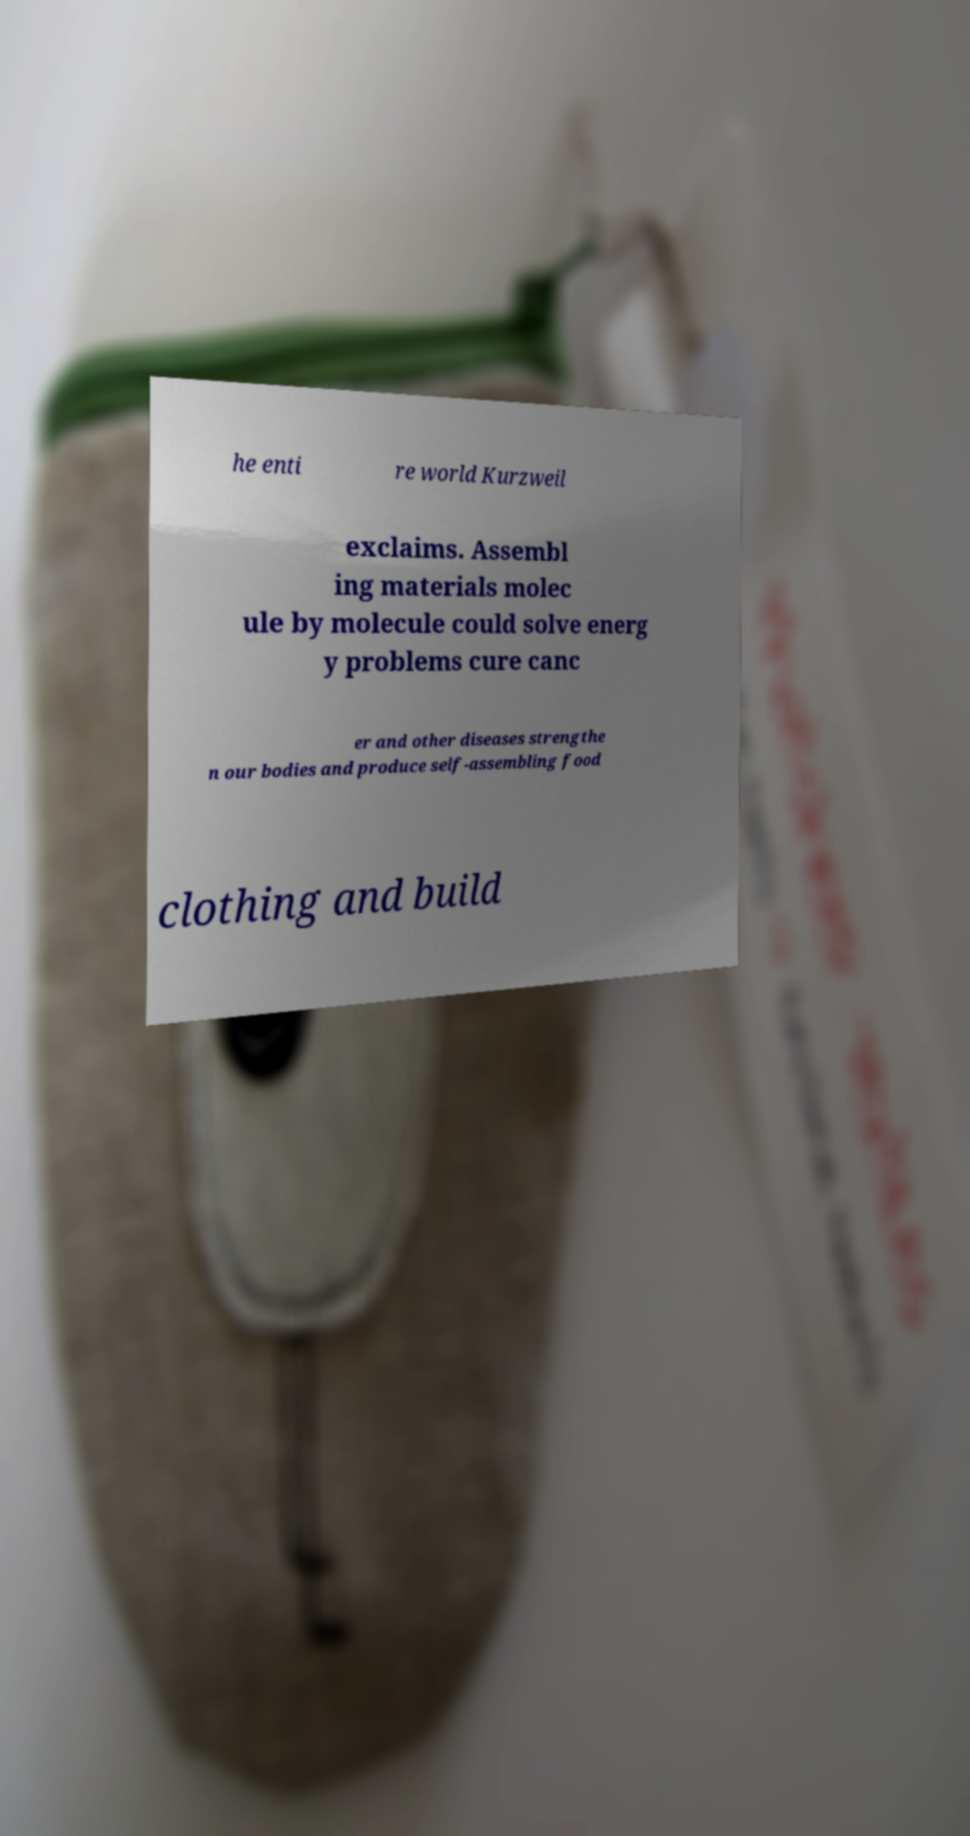Can you read and provide the text displayed in the image?This photo seems to have some interesting text. Can you extract and type it out for me? he enti re world Kurzweil exclaims. Assembl ing materials molec ule by molecule could solve energ y problems cure canc er and other diseases strengthe n our bodies and produce self-assembling food clothing and build 